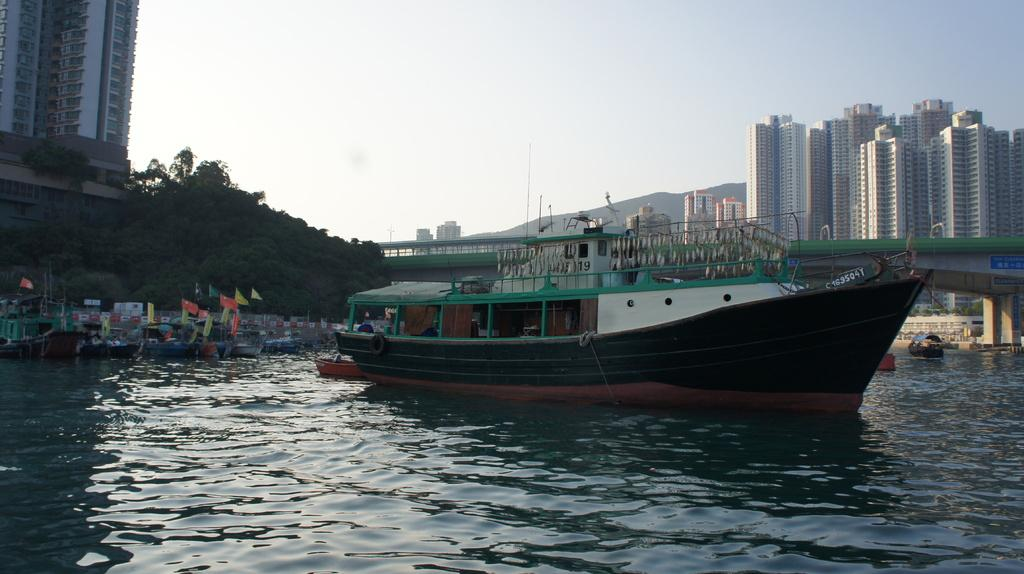<image>
Summarize the visual content of the image. A fishing boat has registry number C163504T in white on it. 